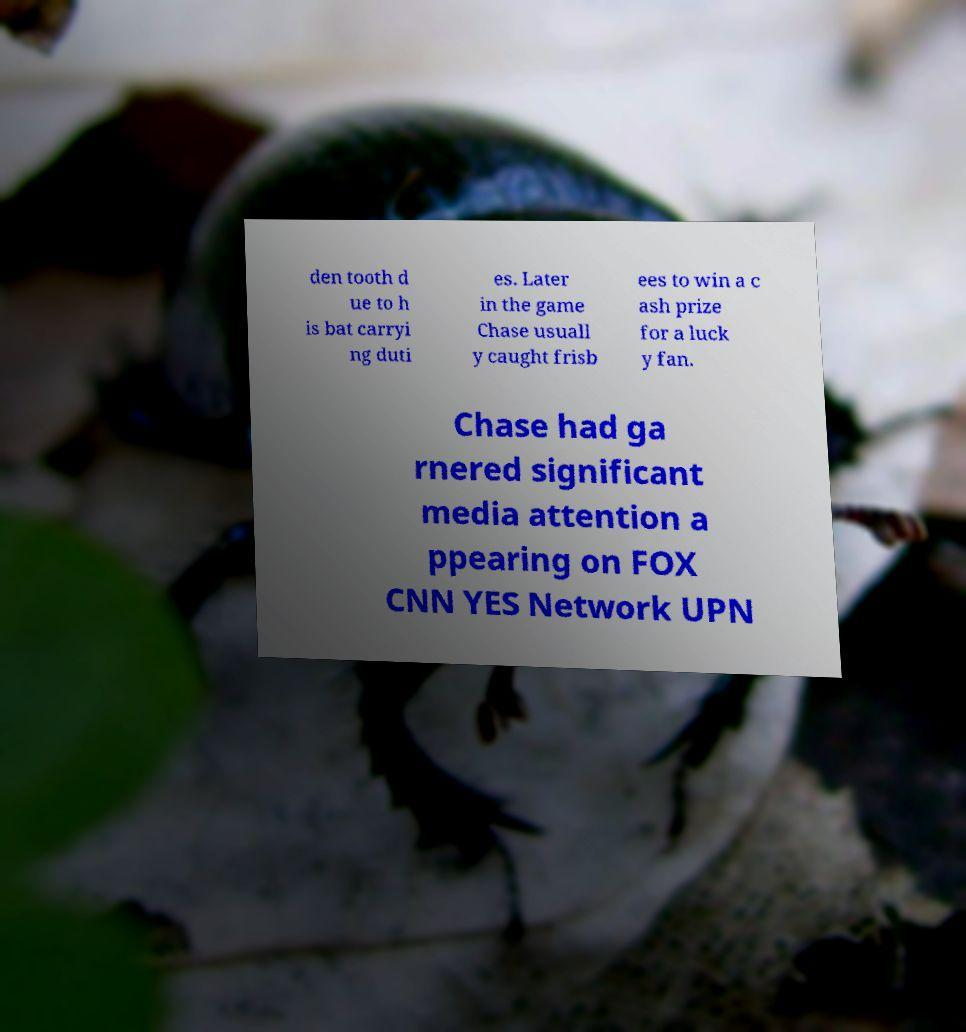Please identify and transcribe the text found in this image. den tooth d ue to h is bat carryi ng duti es. Later in the game Chase usuall y caught frisb ees to win a c ash prize for a luck y fan. Chase had ga rnered significant media attention a ppearing on FOX CNN YES Network UPN 